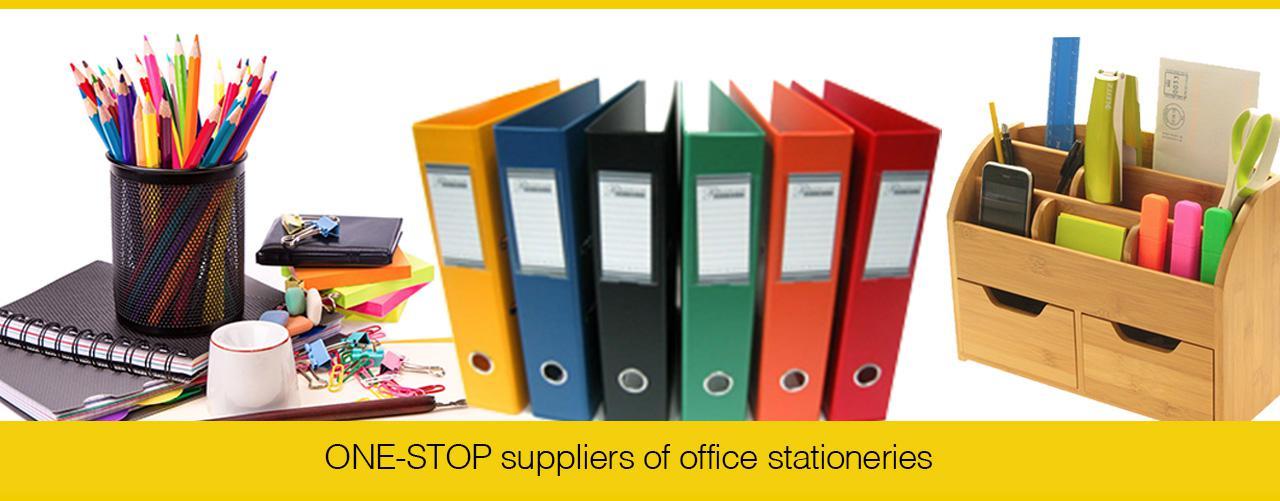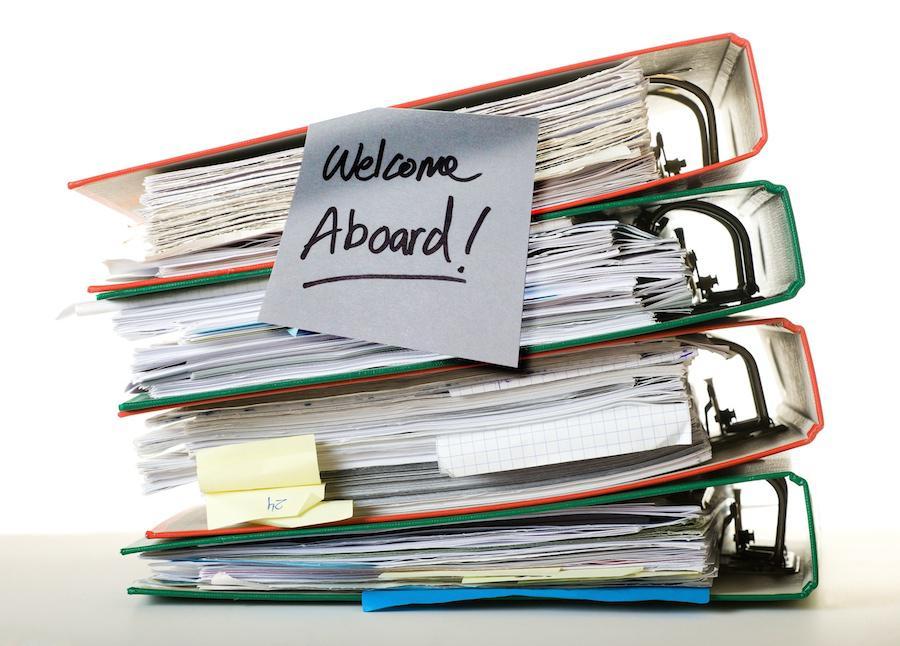The first image is the image on the left, the second image is the image on the right. For the images displayed, is the sentence "A person is grasping a vertical stack of binders in one image." factually correct? Answer yes or no. No. The first image is the image on the left, the second image is the image on the right. Analyze the images presented: Is the assertion "there are at least five colored binders in the image on the left" valid? Answer yes or no. Yes. 